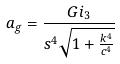Convert formula to latex. <formula><loc_0><loc_0><loc_500><loc_500>a _ { g } = \frac { G i _ { 3 } } { s ^ { 4 } \sqrt { 1 + \frac { k ^ { 4 } } { c ^ { 4 } } } }</formula> 